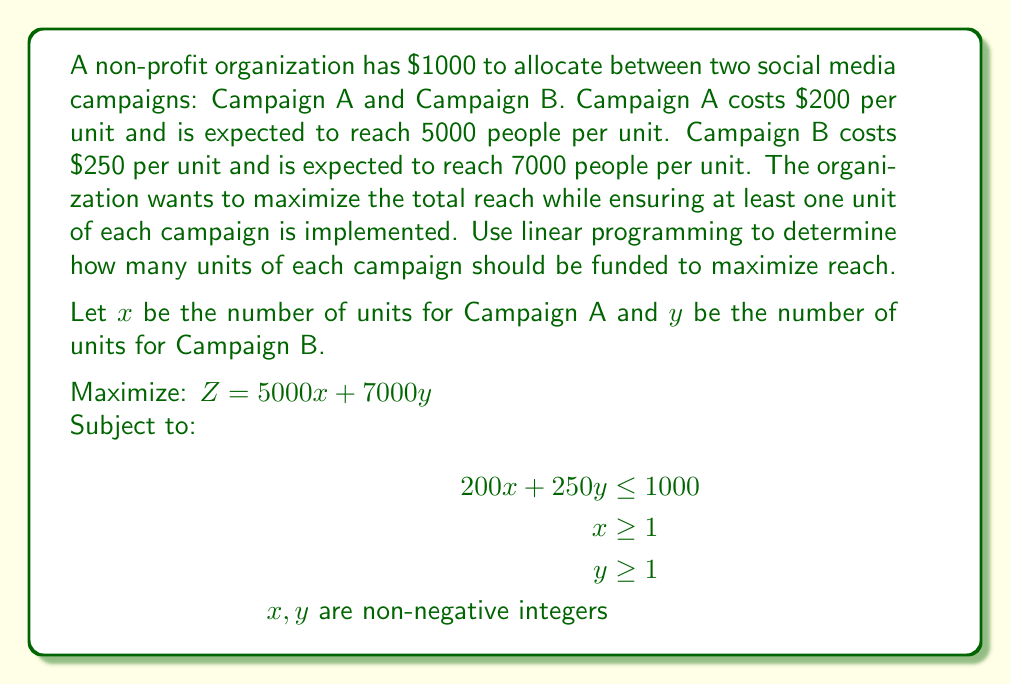Solve this math problem. To solve this linear programming problem, we'll follow these steps:

1) First, we need to graph the constraints:
   $200x + 250y \leq 1000$ (Budget constraint)
   $x \geq 1$
   $y \geq 1$

2) The feasible region is the area that satisfies all constraints.

3) The optimal solution will be at one of the corner points of the feasible region.

4) The corner points are:
   (1, 1), (1, 3), (4, 1)

5) Let's evaluate the objective function $Z = 5000x + 7000y$ at each point:

   At (1, 1): $Z = 5000(1) + 7000(1) = 12,000$
   At (1, 3): $Z = 5000(1) + 7000(3) = 26,000$
   At (4, 1): $Z = 5000(4) + 7000(1) = 27,000$

6) The maximum value of $Z$ occurs at the point (4, 1).

Therefore, the optimal solution is to fund 4 units of Campaign A and 1 unit of Campaign B, reaching a total of 27,000 people.

This solution uses $200(4) + 250(1) = 1050$, which slightly exceeds the budget. Since we're dealing with integer solutions, we need to round down to the nearest feasible solution, which is (3, 1).

At (3, 1): $Z = 5000(3) + 7000(1) = 22,000$

This solution uses $200(3) + 250(1) = 850$, which is within the budget.
Answer: 3 units of Campaign A, 1 unit of Campaign B 